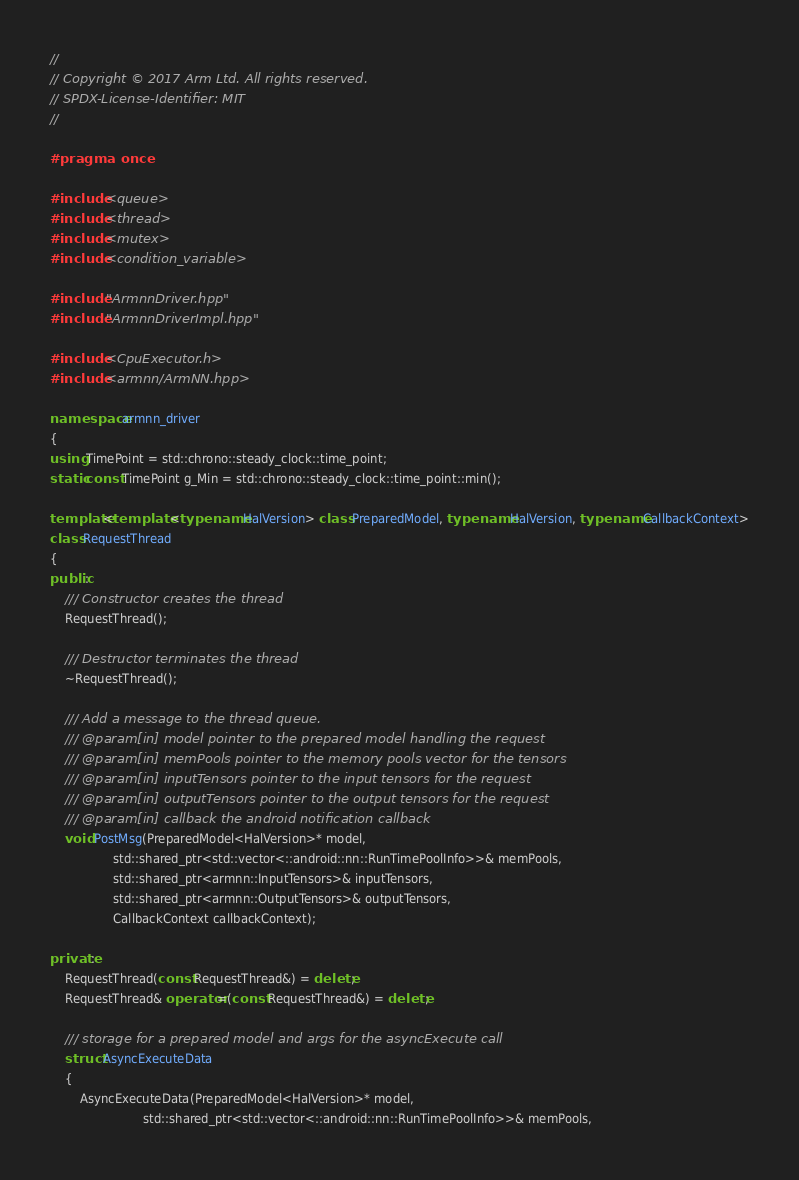<code> <loc_0><loc_0><loc_500><loc_500><_C++_>//
// Copyright © 2017 Arm Ltd. All rights reserved.
// SPDX-License-Identifier: MIT
//

#pragma once

#include <queue>
#include <thread>
#include <mutex>
#include <condition_variable>

#include "ArmnnDriver.hpp"
#include "ArmnnDriverImpl.hpp"

#include <CpuExecutor.h>
#include <armnn/ArmNN.hpp>

namespace armnn_driver
{
using TimePoint = std::chrono::steady_clock::time_point;
static const TimePoint g_Min = std::chrono::steady_clock::time_point::min();

template<template <typename HalVersion> class PreparedModel, typename HalVersion, typename CallbackContext>
class RequestThread
{
public:
    /// Constructor creates the thread
    RequestThread();

    /// Destructor terminates the thread
    ~RequestThread();

    /// Add a message to the thread queue.
    /// @param[in] model pointer to the prepared model handling the request
    /// @param[in] memPools pointer to the memory pools vector for the tensors
    /// @param[in] inputTensors pointer to the input tensors for the request
    /// @param[in] outputTensors pointer to the output tensors for the request
    /// @param[in] callback the android notification callback
    void PostMsg(PreparedModel<HalVersion>* model,
                 std::shared_ptr<std::vector<::android::nn::RunTimePoolInfo>>& memPools,
                 std::shared_ptr<armnn::InputTensors>& inputTensors,
                 std::shared_ptr<armnn::OutputTensors>& outputTensors,
                 CallbackContext callbackContext);

private:
    RequestThread(const RequestThread&) = delete;
    RequestThread& operator=(const RequestThread&) = delete;

    /// storage for a prepared model and args for the asyncExecute call
    struct AsyncExecuteData
    {
        AsyncExecuteData(PreparedModel<HalVersion>* model,
                         std::shared_ptr<std::vector<::android::nn::RunTimePoolInfo>>& memPools,</code> 